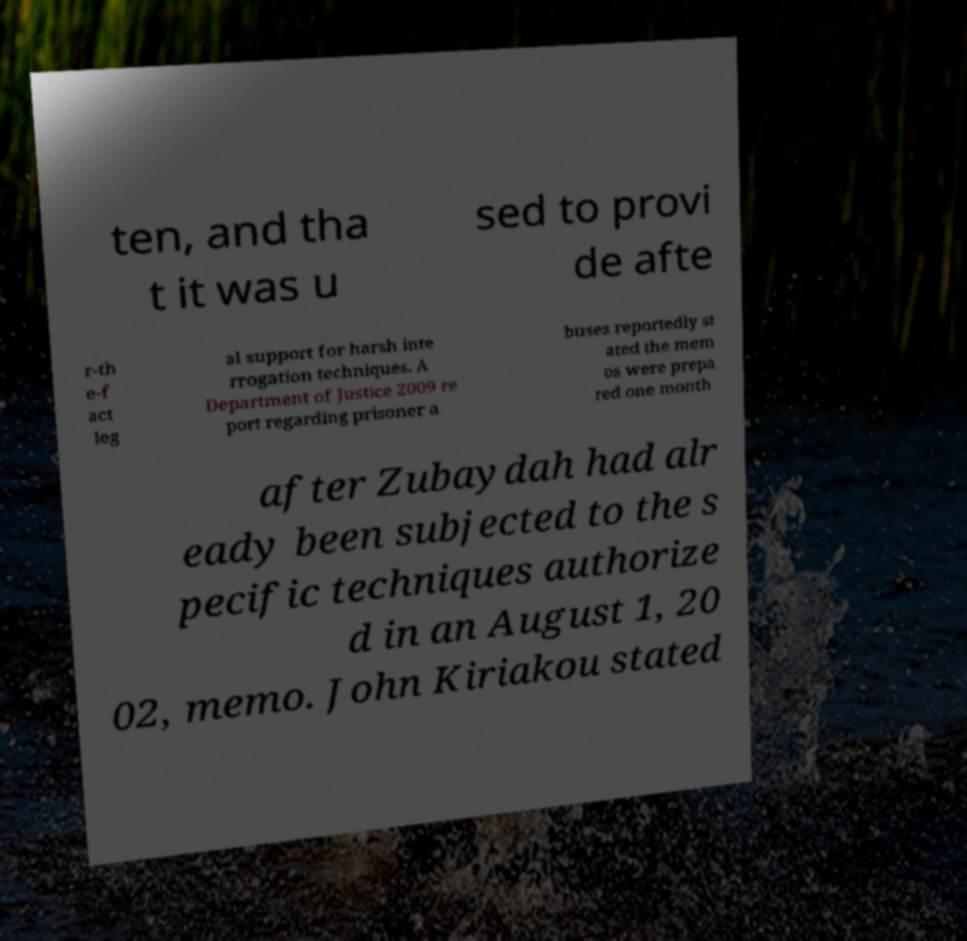I need the written content from this picture converted into text. Can you do that? ten, and tha t it was u sed to provi de afte r-th e-f act leg al support for harsh inte rrogation techniques. A Department of Justice 2009 re port regarding prisoner a buses reportedly st ated the mem os were prepa red one month after Zubaydah had alr eady been subjected to the s pecific techniques authorize d in an August 1, 20 02, memo. John Kiriakou stated 